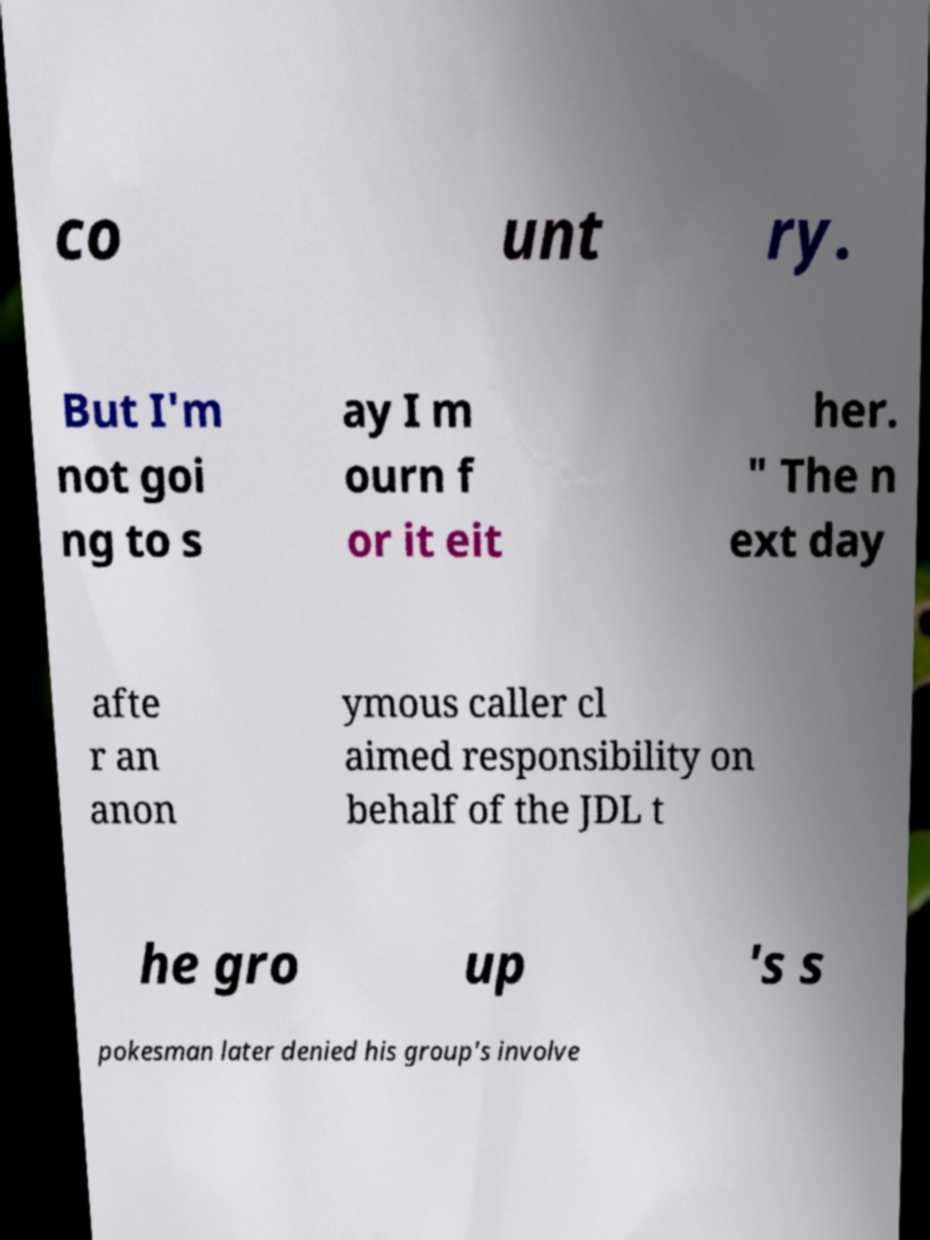Could you assist in decoding the text presented in this image and type it out clearly? co unt ry. But I'm not goi ng to s ay I m ourn f or it eit her. " The n ext day afte r an anon ymous caller cl aimed responsibility on behalf of the JDL t he gro up 's s pokesman later denied his group's involve 